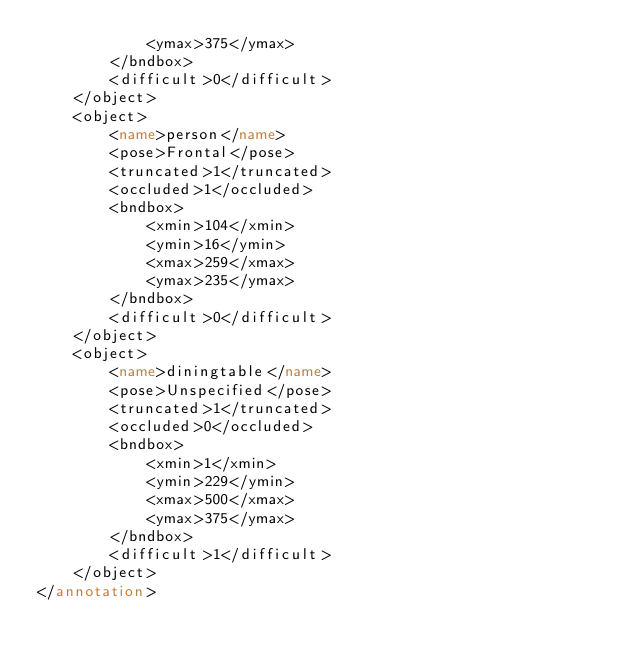<code> <loc_0><loc_0><loc_500><loc_500><_XML_>			<ymax>375</ymax>
		</bndbox>
		<difficult>0</difficult>
	</object>
	<object>
		<name>person</name>
		<pose>Frontal</pose>
		<truncated>1</truncated>
		<occluded>1</occluded>
		<bndbox>
			<xmin>104</xmin>
			<ymin>16</ymin>
			<xmax>259</xmax>
			<ymax>235</ymax>
		</bndbox>
		<difficult>0</difficult>
	</object>
	<object>
		<name>diningtable</name>
		<pose>Unspecified</pose>
		<truncated>1</truncated>
		<occluded>0</occluded>
		<bndbox>
			<xmin>1</xmin>
			<ymin>229</ymin>
			<xmax>500</xmax>
			<ymax>375</ymax>
		</bndbox>
		<difficult>1</difficult>
	</object>
</annotation>
</code> 